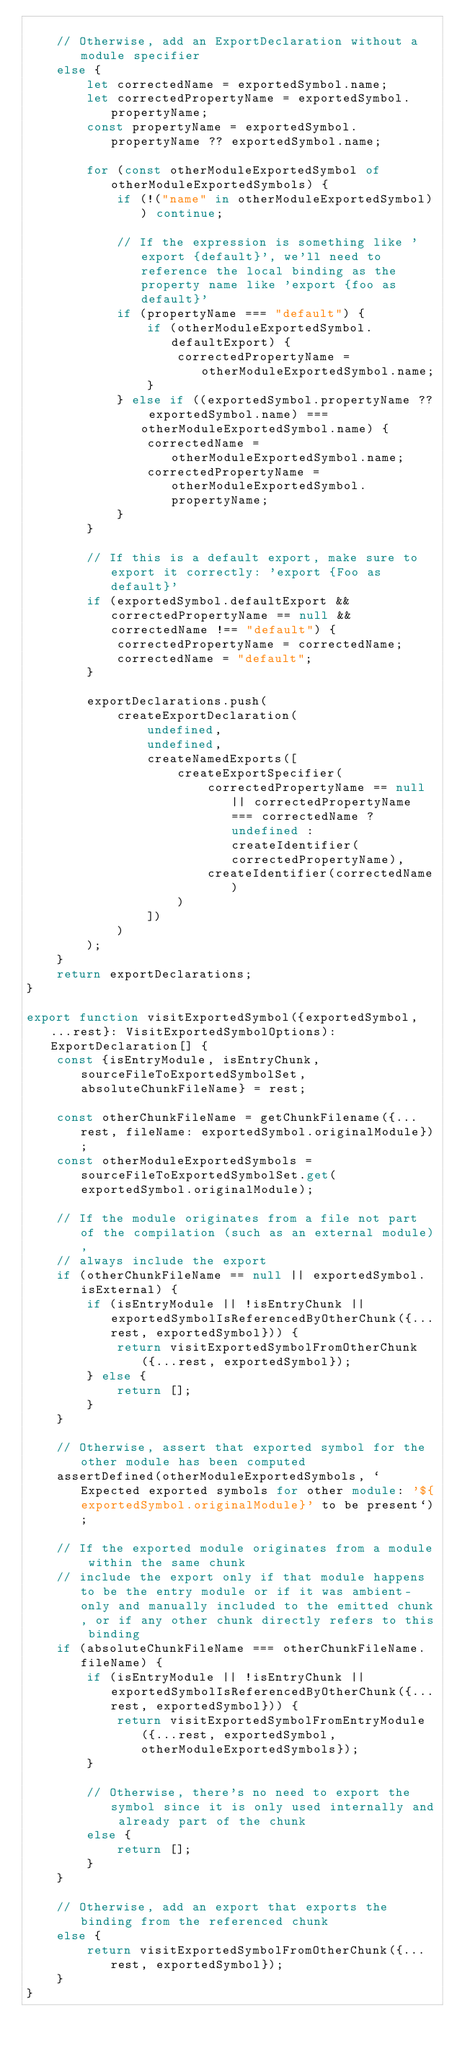<code> <loc_0><loc_0><loc_500><loc_500><_TypeScript_>
	// Otherwise, add an ExportDeclaration without a module specifier
	else {
		let correctedName = exportedSymbol.name;
		let correctedPropertyName = exportedSymbol.propertyName;
		const propertyName = exportedSymbol.propertyName ?? exportedSymbol.name;

		for (const otherModuleExportedSymbol of otherModuleExportedSymbols) {
			if (!("name" in otherModuleExportedSymbol)) continue;

			// If the expression is something like 'export {default}', we'll need to reference the local binding as the property name like 'export {foo as default}'
			if (propertyName === "default") {
				if (otherModuleExportedSymbol.defaultExport) {
					correctedPropertyName = otherModuleExportedSymbol.name;
				}
			} else if ((exportedSymbol.propertyName ?? exportedSymbol.name) === otherModuleExportedSymbol.name) {
				correctedName = otherModuleExportedSymbol.name;
				correctedPropertyName = otherModuleExportedSymbol.propertyName;
			}
		}

		// If this is a default export, make sure to export it correctly: 'export {Foo as default}'
		if (exportedSymbol.defaultExport && correctedPropertyName == null && correctedName !== "default") {
			correctedPropertyName = correctedName;
			correctedName = "default";
		}

		exportDeclarations.push(
			createExportDeclaration(
				undefined,
				undefined,
				createNamedExports([
					createExportSpecifier(
						correctedPropertyName == null || correctedPropertyName === correctedName ? undefined : createIdentifier(correctedPropertyName),
						createIdentifier(correctedName)
					)
				])
			)
		);
	}
	return exportDeclarations;
}

export function visitExportedSymbol({exportedSymbol, ...rest}: VisitExportedSymbolOptions): ExportDeclaration[] {
	const {isEntryModule, isEntryChunk, sourceFileToExportedSymbolSet, absoluteChunkFileName} = rest;

	const otherChunkFileName = getChunkFilename({...rest, fileName: exportedSymbol.originalModule});
	const otherModuleExportedSymbols = sourceFileToExportedSymbolSet.get(exportedSymbol.originalModule);

	// If the module originates from a file not part of the compilation (such as an external module),
	// always include the export
	if (otherChunkFileName == null || exportedSymbol.isExternal) {
		if (isEntryModule || !isEntryChunk || exportedSymbolIsReferencedByOtherChunk({...rest, exportedSymbol})) {
			return visitExportedSymbolFromOtherChunk({...rest, exportedSymbol});
		} else {
			return [];
		}
	}

	// Otherwise, assert that exported symbol for the other module has been computed
	assertDefined(otherModuleExportedSymbols, `Expected exported symbols for other module: '${exportedSymbol.originalModule}' to be present`);

	// If the exported module originates from a module within the same chunk
	// include the export only if that module happens to be the entry module or if it was ambient-only and manually included to the emitted chunk, or if any other chunk directly refers to this binding
	if (absoluteChunkFileName === otherChunkFileName.fileName) {
		if (isEntryModule || !isEntryChunk || exportedSymbolIsReferencedByOtherChunk({...rest, exportedSymbol})) {
			return visitExportedSymbolFromEntryModule({...rest, exportedSymbol, otherModuleExportedSymbols});
		}

		// Otherwise, there's no need to export the symbol since it is only used internally and already part of the chunk
		else {
			return [];
		}
	}

	// Otherwise, add an export that exports the binding from the referenced chunk
	else {
		return visitExportedSymbolFromOtherChunk({...rest, exportedSymbol});
	}
}
</code> 